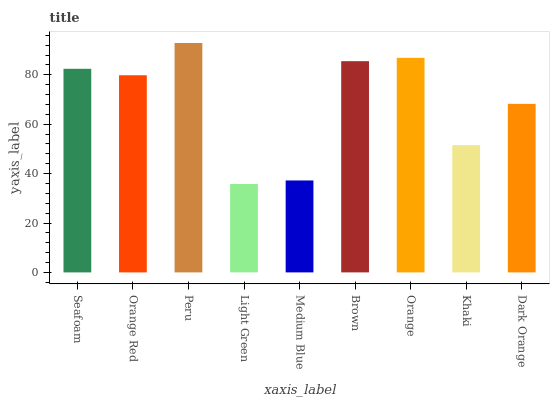Is Light Green the minimum?
Answer yes or no. Yes. Is Peru the maximum?
Answer yes or no. Yes. Is Orange Red the minimum?
Answer yes or no. No. Is Orange Red the maximum?
Answer yes or no. No. Is Seafoam greater than Orange Red?
Answer yes or no. Yes. Is Orange Red less than Seafoam?
Answer yes or no. Yes. Is Orange Red greater than Seafoam?
Answer yes or no. No. Is Seafoam less than Orange Red?
Answer yes or no. No. Is Orange Red the high median?
Answer yes or no. Yes. Is Orange Red the low median?
Answer yes or no. Yes. Is Peru the high median?
Answer yes or no. No. Is Medium Blue the low median?
Answer yes or no. No. 